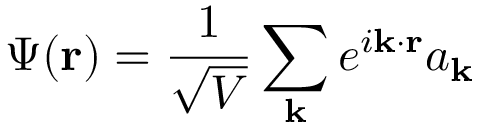<formula> <loc_0><loc_0><loc_500><loc_500>\Psi ( r ) = { \frac { 1 } { \sqrt { V } } } \sum _ { k } e ^ { i k \cdot r } a _ { k }</formula> 